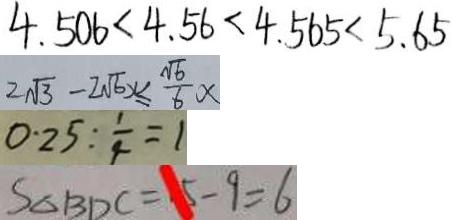Convert formula to latex. <formula><loc_0><loc_0><loc_500><loc_500>4 . 5 0 6 < 4 . 5 6 < 4 . 5 6 5 < 5 . 6 5 
 2 \sqrt { 3 } - 2 \sqrt { 6 } x \leq \frac { \sqrt { 6 } } { 6 } x 
 0 . 2 5 : \frac { 1 } { 4 } = 1 
 S _ { \Delta B D C } = 1 5 - 9 = 6</formula> 